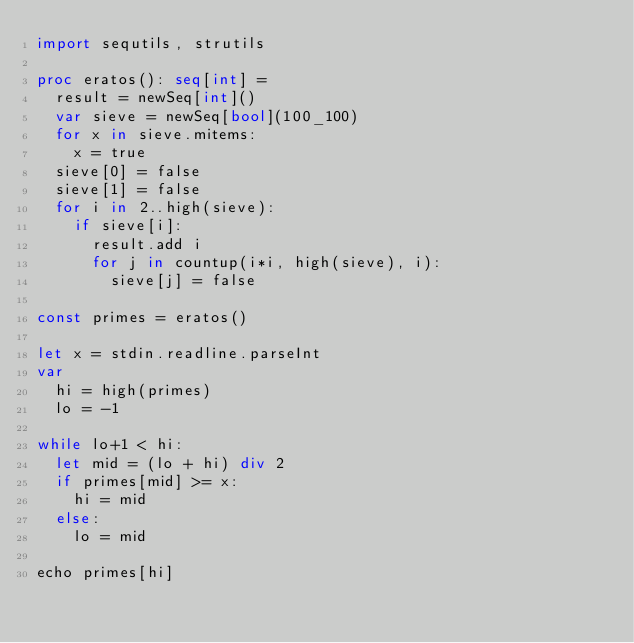<code> <loc_0><loc_0><loc_500><loc_500><_Nim_>import sequtils, strutils

proc eratos(): seq[int] =
  result = newSeq[int]()
  var sieve = newSeq[bool](100_100)
  for x in sieve.mitems:
    x = true
  sieve[0] = false
  sieve[1] = false
  for i in 2..high(sieve):
    if sieve[i]:
      result.add i
      for j in countup(i*i, high(sieve), i):
        sieve[j] = false

const primes = eratos()

let x = stdin.readline.parseInt
var
  hi = high(primes)
  lo = -1

while lo+1 < hi:
  let mid = (lo + hi) div 2
  if primes[mid] >= x:
    hi = mid
  else:
    lo = mid

echo primes[hi]
</code> 